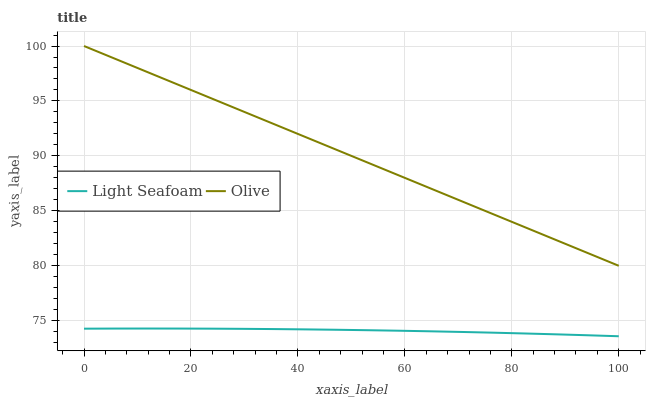Does Light Seafoam have the minimum area under the curve?
Answer yes or no. Yes. Does Olive have the maximum area under the curve?
Answer yes or no. Yes. Does Light Seafoam have the maximum area under the curve?
Answer yes or no. No. Is Olive the smoothest?
Answer yes or no. Yes. Is Light Seafoam the roughest?
Answer yes or no. Yes. Is Light Seafoam the smoothest?
Answer yes or no. No. Does Light Seafoam have the lowest value?
Answer yes or no. Yes. Does Olive have the highest value?
Answer yes or no. Yes. Does Light Seafoam have the highest value?
Answer yes or no. No. Is Light Seafoam less than Olive?
Answer yes or no. Yes. Is Olive greater than Light Seafoam?
Answer yes or no. Yes. Does Light Seafoam intersect Olive?
Answer yes or no. No. 